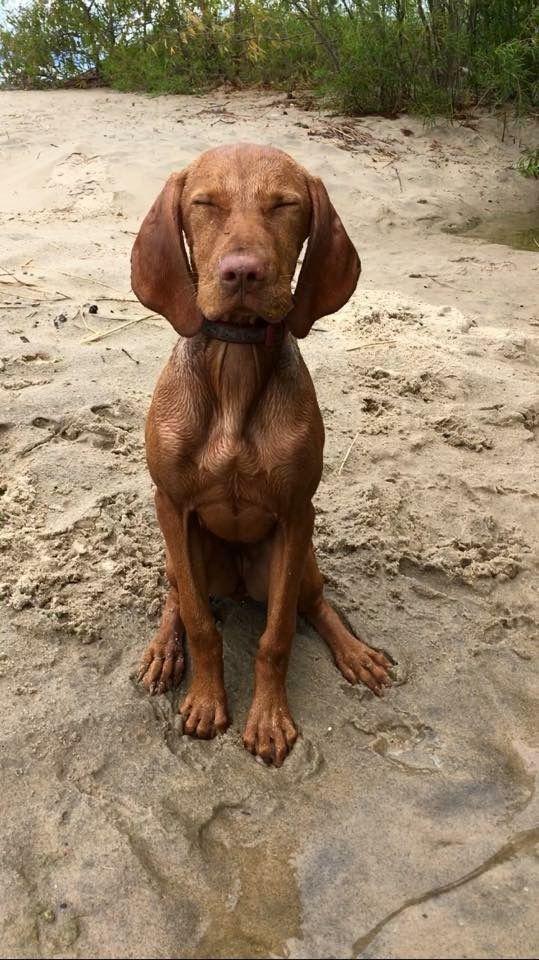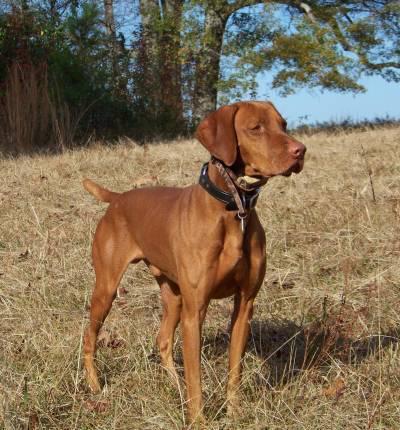The first image is the image on the left, the second image is the image on the right. Evaluate the accuracy of this statement regarding the images: "In at least one image there is a shotgun behind a dog with his tongue stuck out.". Is it true? Answer yes or no. No. The first image is the image on the left, the second image is the image on the right. For the images shown, is this caption "A dog is laying down." true? Answer yes or no. No. 